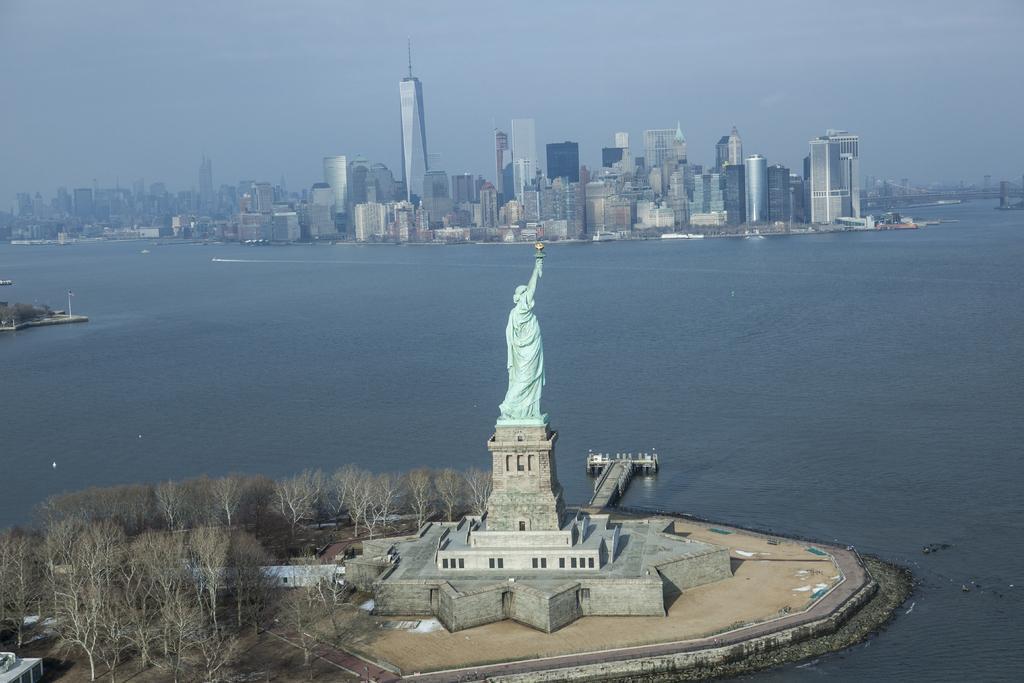Could you give a brief overview of what you see in this image? In the image there is a statue of liberty in the small pillar. Below that there is a platform with design. And also there are trees. Behind the statue there is water. In the background there are many buildings. At the top of the image there is a sky. 